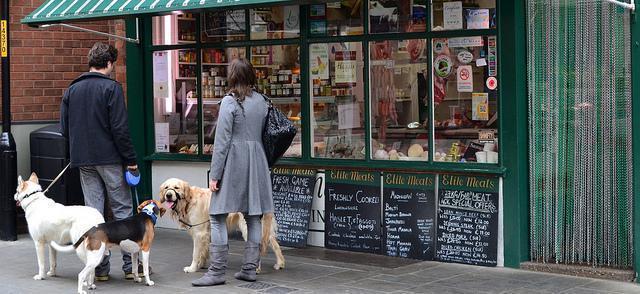What type of animals are shown?
Make your selection from the four choices given to correctly answer the question.
Options: Stuffed, aquatic, wild, domestic. Domestic. 